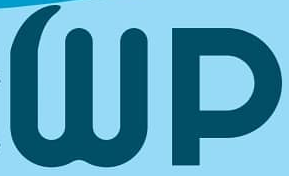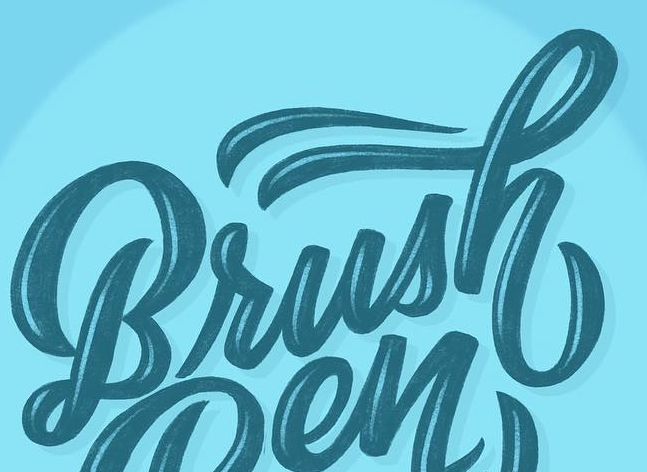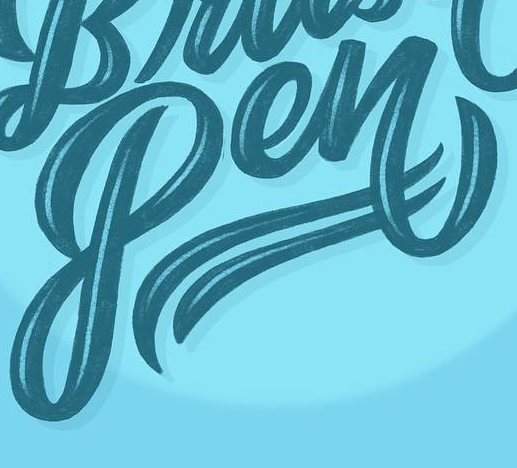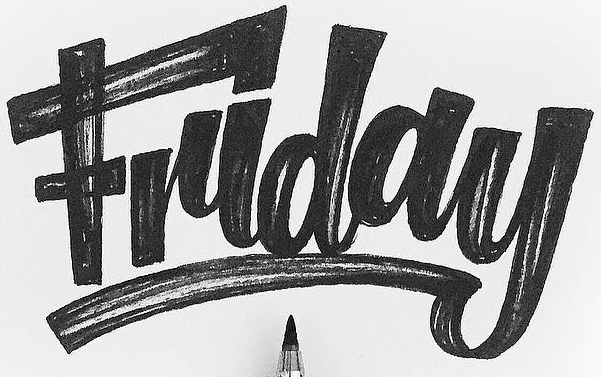What text is displayed in these images sequentially, separated by a semicolon? Wp; Brush; Pen; Friday 